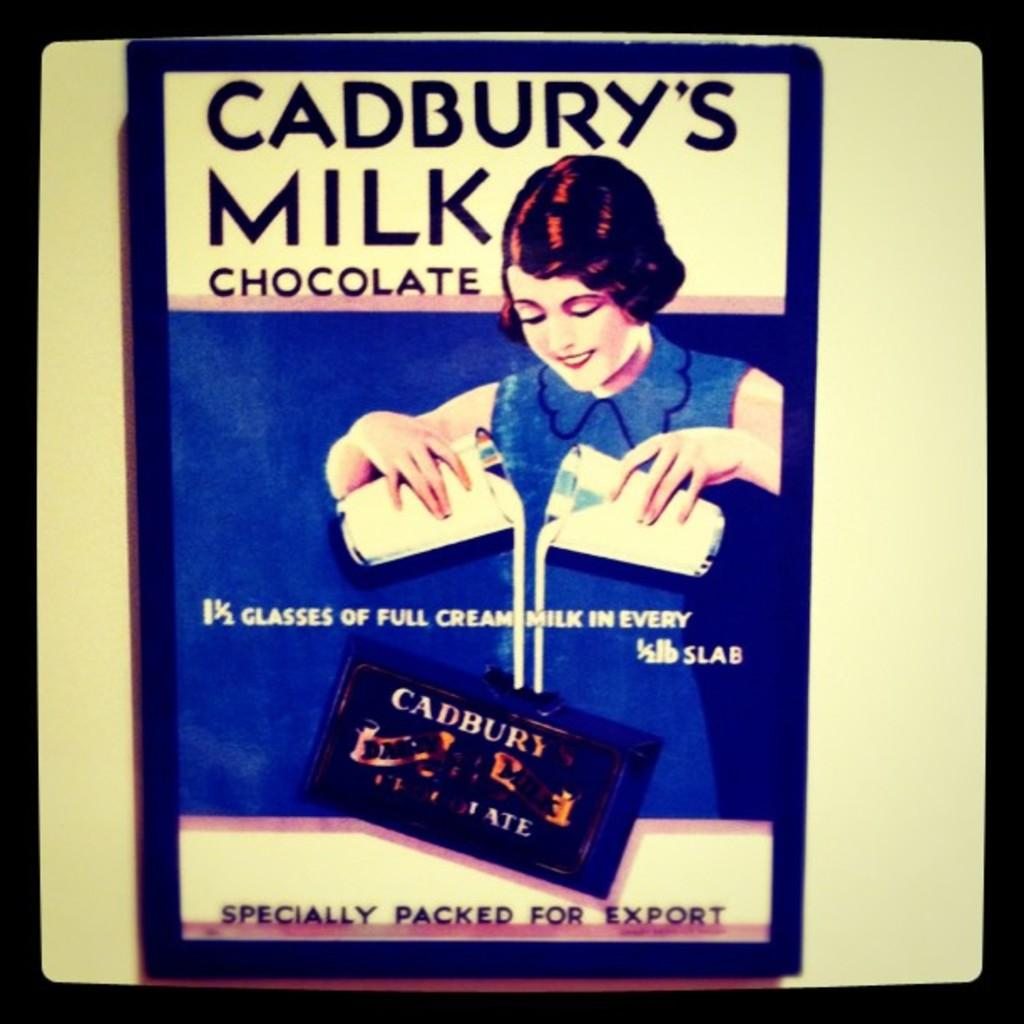<image>
Summarize the visual content of the image. An old ad advertises Cadbury's milk chocolate bars. 